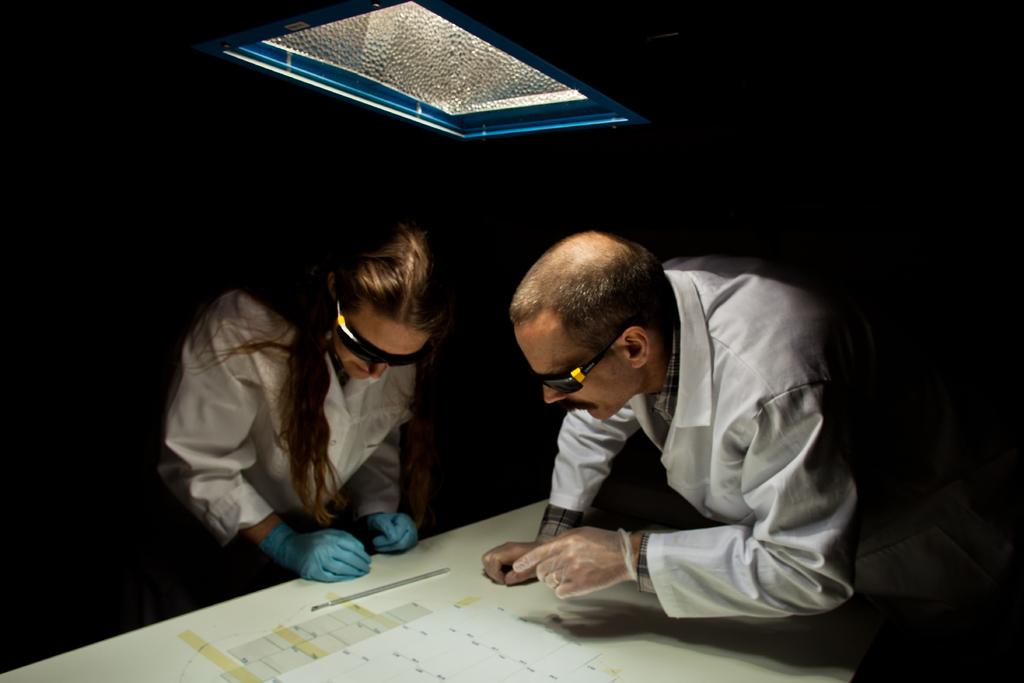What can be seen in the image that provides illumination? There is light in the image. How many people are present in the image? There are two people in the image. What are the people wearing on their faces? The people are wearing goggles. What color are the shirts worn by the people in the image? The people are wearing white color shirts. What piece of furniture is present in the image? There is a table in the image. What is placed on the table in the image? There is a paper on the table. What type of pet can be seen in the image? There is no pet present in the image. What wish is being granted to the people in the image? There is no indication of a wish being granted in the image. 